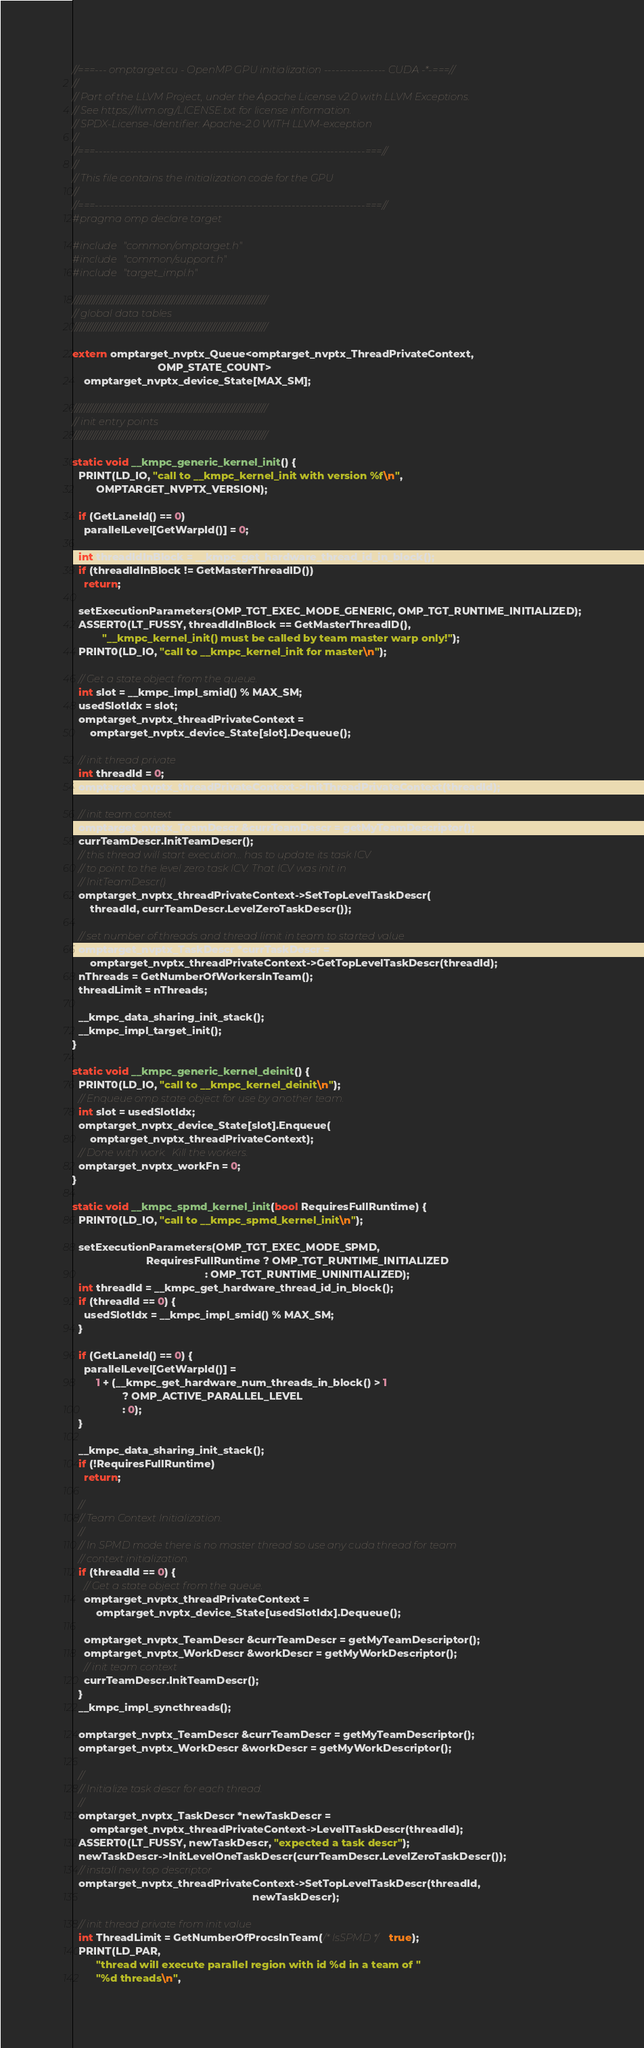Convert code to text. <code><loc_0><loc_0><loc_500><loc_500><_Cuda_>//===--- omptarget.cu - OpenMP GPU initialization ---------------- CUDA -*-===//
//
// Part of the LLVM Project, under the Apache License v2.0 with LLVM Exceptions.
// See https://llvm.org/LICENSE.txt for license information.
// SPDX-License-Identifier: Apache-2.0 WITH LLVM-exception
//
//===----------------------------------------------------------------------===//
//
// This file contains the initialization code for the GPU
//
//===----------------------------------------------------------------------===//
#pragma omp declare target

#include "common/omptarget.h"
#include "common/support.h"
#include "target_impl.h"

////////////////////////////////////////////////////////////////////////////////
// global data tables
////////////////////////////////////////////////////////////////////////////////

extern omptarget_nvptx_Queue<omptarget_nvptx_ThreadPrivateContext,
                             OMP_STATE_COUNT>
    omptarget_nvptx_device_State[MAX_SM];

////////////////////////////////////////////////////////////////////////////////
// init entry points
////////////////////////////////////////////////////////////////////////////////

static void __kmpc_generic_kernel_init() {
  PRINT(LD_IO, "call to __kmpc_kernel_init with version %f\n",
        OMPTARGET_NVPTX_VERSION);

  if (GetLaneId() == 0)
    parallelLevel[GetWarpId()] = 0;

  int threadIdInBlock = __kmpc_get_hardware_thread_id_in_block();
  if (threadIdInBlock != GetMasterThreadID())
    return;

  setExecutionParameters(OMP_TGT_EXEC_MODE_GENERIC, OMP_TGT_RUNTIME_INITIALIZED);
  ASSERT0(LT_FUSSY, threadIdInBlock == GetMasterThreadID(),
          "__kmpc_kernel_init() must be called by team master warp only!");
  PRINT0(LD_IO, "call to __kmpc_kernel_init for master\n");

  // Get a state object from the queue.
  int slot = __kmpc_impl_smid() % MAX_SM;
  usedSlotIdx = slot;
  omptarget_nvptx_threadPrivateContext =
      omptarget_nvptx_device_State[slot].Dequeue();

  // init thread private
  int threadId = 0;
  omptarget_nvptx_threadPrivateContext->InitThreadPrivateContext(threadId);

  // init team context
  omptarget_nvptx_TeamDescr &currTeamDescr = getMyTeamDescriptor();
  currTeamDescr.InitTeamDescr();
  // this thread will start execution... has to update its task ICV
  // to point to the level zero task ICV. That ICV was init in
  // InitTeamDescr()
  omptarget_nvptx_threadPrivateContext->SetTopLevelTaskDescr(
      threadId, currTeamDescr.LevelZeroTaskDescr());

  // set number of threads and thread limit in team to started value
  omptarget_nvptx_TaskDescr *currTaskDescr =
      omptarget_nvptx_threadPrivateContext->GetTopLevelTaskDescr(threadId);
  nThreads = GetNumberOfWorkersInTeam();
  threadLimit = nThreads;

  __kmpc_data_sharing_init_stack();
  __kmpc_impl_target_init();
}

static void __kmpc_generic_kernel_deinit() {
  PRINT0(LD_IO, "call to __kmpc_kernel_deinit\n");
  // Enqueue omp state object for use by another team.
  int slot = usedSlotIdx;
  omptarget_nvptx_device_State[slot].Enqueue(
      omptarget_nvptx_threadPrivateContext);
  // Done with work.  Kill the workers.
  omptarget_nvptx_workFn = 0;
}

static void __kmpc_spmd_kernel_init(bool RequiresFullRuntime) {
  PRINT0(LD_IO, "call to __kmpc_spmd_kernel_init\n");

  setExecutionParameters(OMP_TGT_EXEC_MODE_SPMD,
                         RequiresFullRuntime ? OMP_TGT_RUNTIME_INITIALIZED
                                             : OMP_TGT_RUNTIME_UNINITIALIZED);
  int threadId = __kmpc_get_hardware_thread_id_in_block();
  if (threadId == 0) {
    usedSlotIdx = __kmpc_impl_smid() % MAX_SM;
  }

  if (GetLaneId() == 0) {
    parallelLevel[GetWarpId()] =
        1 + (__kmpc_get_hardware_num_threads_in_block() > 1
                 ? OMP_ACTIVE_PARALLEL_LEVEL
                 : 0);
  }

  __kmpc_data_sharing_init_stack();
  if (!RequiresFullRuntime)
    return;

  //
  // Team Context Initialization.
  //
  // In SPMD mode there is no master thread so use any cuda thread for team
  // context initialization.
  if (threadId == 0) {
    // Get a state object from the queue.
    omptarget_nvptx_threadPrivateContext =
        omptarget_nvptx_device_State[usedSlotIdx].Dequeue();

    omptarget_nvptx_TeamDescr &currTeamDescr = getMyTeamDescriptor();
    omptarget_nvptx_WorkDescr &workDescr = getMyWorkDescriptor();
    // init team context
    currTeamDescr.InitTeamDescr();
  }
  __kmpc_impl_syncthreads();

  omptarget_nvptx_TeamDescr &currTeamDescr = getMyTeamDescriptor();
  omptarget_nvptx_WorkDescr &workDescr = getMyWorkDescriptor();

  //
  // Initialize task descr for each thread.
  //
  omptarget_nvptx_TaskDescr *newTaskDescr =
      omptarget_nvptx_threadPrivateContext->Level1TaskDescr(threadId);
  ASSERT0(LT_FUSSY, newTaskDescr, "expected a task descr");
  newTaskDescr->InitLevelOneTaskDescr(currTeamDescr.LevelZeroTaskDescr());
  // install new top descriptor
  omptarget_nvptx_threadPrivateContext->SetTopLevelTaskDescr(threadId,
                                                             newTaskDescr);

  // init thread private from init value
  int ThreadLimit = GetNumberOfProcsInTeam(/* IsSPMD */ true);
  PRINT(LD_PAR,
        "thread will execute parallel region with id %d in a team of "
        "%d threads\n",</code> 